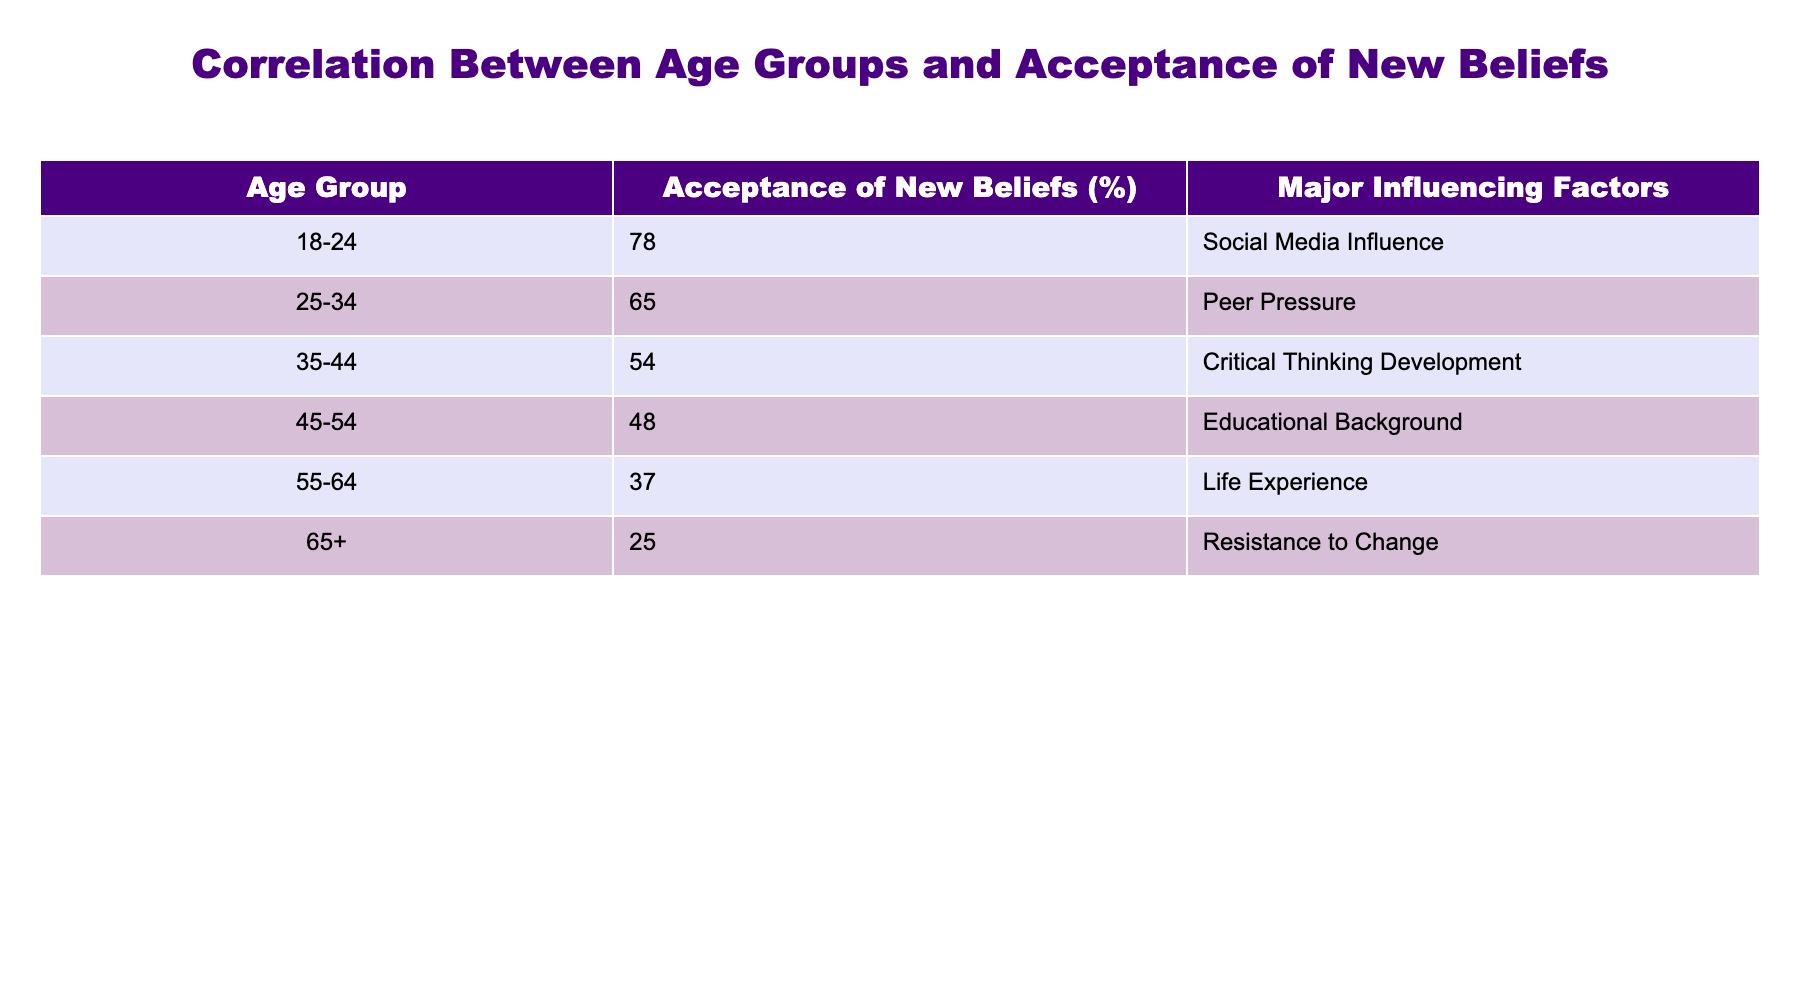What age group has the highest acceptance of new beliefs? The age group 18-24 has the highest acceptance rate of 78%, as indicated in the table under the "Acceptance of New Beliefs (%)" column.
Answer: 18-24 What is the acceptance rate of the age group 55-64? The acceptance rate for the age group 55-64 is listed as 37% in the table under the "Acceptance of New Beliefs (%)" column.
Answer: 37% Is social media influence a major factor for older age groups? No, social media influence is identified as a major factor for the age group 18-24, not for older age groups like 55-64 and 65+, where resistance to change and life experience are influenced instead.
Answer: No What is the difference in acceptance rates between the age groups 25-34 and 45-54? The acceptance rate for the age group 25-34 is 65%, while for the age group 45-54 it is 48%. The difference is 65 - 48 = 17%.
Answer: 17% What is the average acceptance rate for age groups 35-44 and 45-54? The acceptance rate for 35-44 is 54%, and for 45-54 it is 48%. The average is calculated as (54 + 48) / 2 = 51%.
Answer: 51% Which age group shows the greatest resistance to change based on the influencing factors? The age group 65+ shows the greatest resistance to change, as their acceptance of new beliefs is only 25%, attributed to their resistance factor.
Answer: 65+ What major influencing factor is most associated with lower age groups? Social media influence, which is notably associated with the age group 18-24, is the major factor for lower age groups, correlating with their higher acceptance rates of new beliefs.
Answer: Social Media Influence What age group is most affected by educational background as a major influencing factor? The age group 45-54 is indicated in the table as most affected by educational background, with an acceptance rate of 48%.
Answer: 45-54 